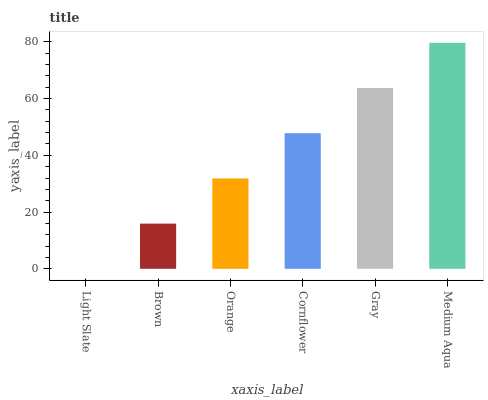Is Light Slate the minimum?
Answer yes or no. Yes. Is Medium Aqua the maximum?
Answer yes or no. Yes. Is Brown the minimum?
Answer yes or no. No. Is Brown the maximum?
Answer yes or no. No. Is Brown greater than Light Slate?
Answer yes or no. Yes. Is Light Slate less than Brown?
Answer yes or no. Yes. Is Light Slate greater than Brown?
Answer yes or no. No. Is Brown less than Light Slate?
Answer yes or no. No. Is Cornflower the high median?
Answer yes or no. Yes. Is Orange the low median?
Answer yes or no. Yes. Is Orange the high median?
Answer yes or no. No. Is Cornflower the low median?
Answer yes or no. No. 